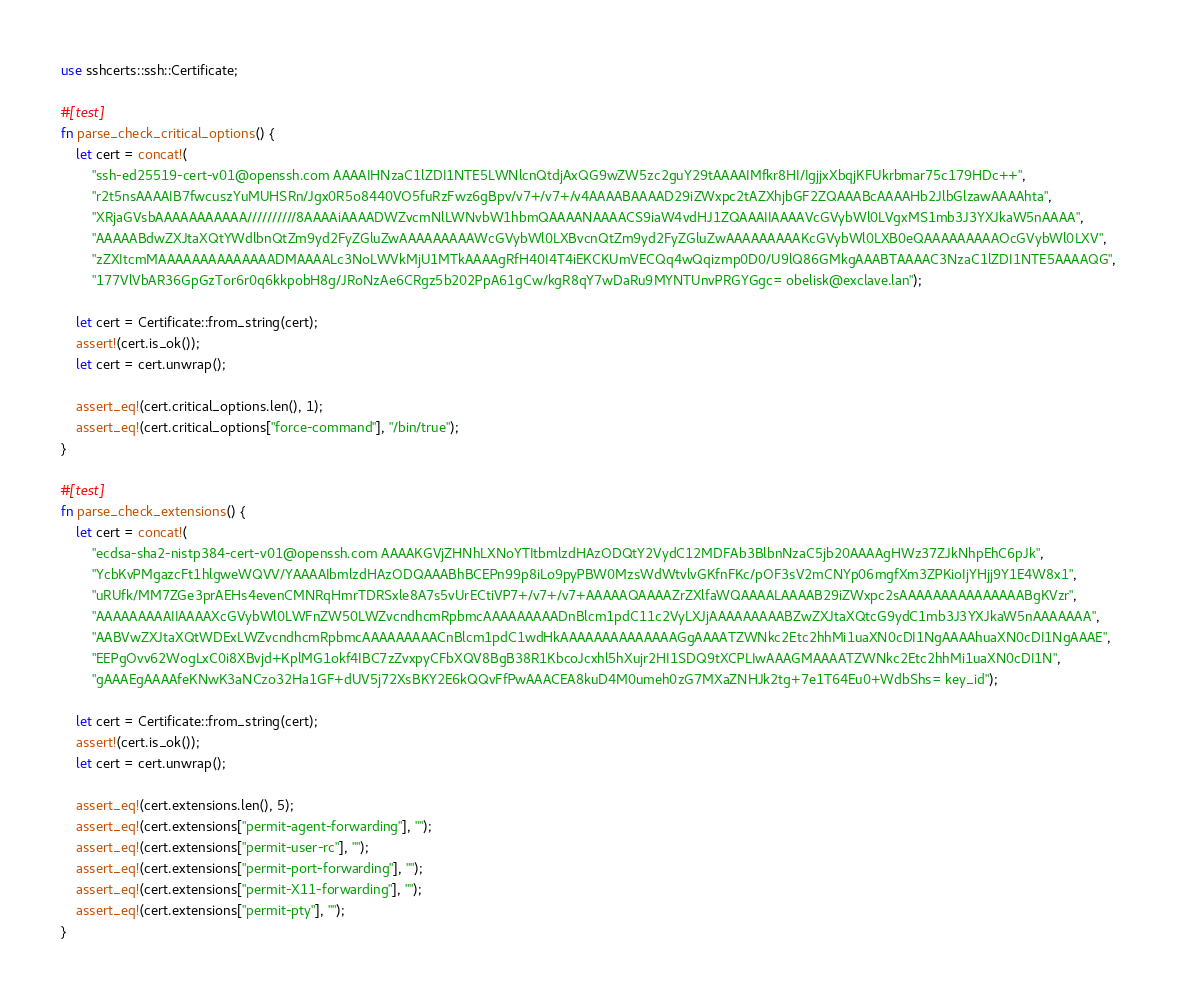<code> <loc_0><loc_0><loc_500><loc_500><_Rust_>use sshcerts::ssh::Certificate;

#[test]
fn parse_check_critical_options() {
    let cert = concat!(
        "ssh-ed25519-cert-v01@openssh.com AAAAIHNzaC1lZDI1NTE5LWNlcnQtdjAxQG9wZW5zc2guY29tAAAAIMfkr8HI/IgjjxXbqjKFUkrbmar75c179HDc++",
        "r2t5nsAAAAIB7fwcuszYuMUHSRn/Jgx0R5o8440VO5fuRzFwz6gBpv/v7+/v7+/v4AAAABAAAAD29iZWxpc2tAZXhjbGF2ZQAAABcAAAAHb2JlbGlzawAAAAhta",
        "XRjaGVsbAAAAAAAAAAA//////////8AAAAiAAAADWZvcmNlLWNvbW1hbmQAAAANAAAACS9iaW4vdHJ1ZQAAAIIAAAAVcGVybWl0LVgxMS1mb3J3YXJkaW5nAAAA",
        "AAAAABdwZXJtaXQtYWdlbnQtZm9yd2FyZGluZwAAAAAAAAAWcGVybWl0LXBvcnQtZm9yd2FyZGluZwAAAAAAAAAKcGVybWl0LXB0eQAAAAAAAAAOcGVybWl0LXV",
        "zZXItcmMAAAAAAAAAAAAAADMAAAALc3NoLWVkMjU1MTkAAAAgRfH40I4T4iEKCKUmVECQq4wQqizmp0D0/U9lQ86GMkgAAABTAAAAC3NzaC1lZDI1NTE5AAAAQG",
        "177VlVbAR36GpGzTor6r0q6kkpobH8g/JRoNzAe6CRgz5b202PpA61gCw/kgR8qY7wDaRu9MYNTUnvPRGYGgc= obelisk@exclave.lan");

    let cert = Certificate::from_string(cert);
    assert!(cert.is_ok());
    let cert = cert.unwrap();

    assert_eq!(cert.critical_options.len(), 1);
    assert_eq!(cert.critical_options["force-command"], "/bin/true");
}

#[test]
fn parse_check_extensions() {
    let cert = concat!(
        "ecdsa-sha2-nistp384-cert-v01@openssh.com AAAAKGVjZHNhLXNoYTItbmlzdHAzODQtY2VydC12MDFAb3BlbnNzaC5jb20AAAAgHWz37ZJkNhpEhC6pJk",
        "YcbKvPMgazcFt1hlgweWQVV/YAAAAIbmlzdHAzODQAAABhBCEPn99p8iLo9pyPBW0MzsWdWtvlvGKfnFKc/pOF3sV2mCNYp06mgfXm3ZPKioIjYHjj9Y1E4W8x1",
        "uRUfk/MM7ZGe3prAEHs4evenCMNRqHmrTDRSxle8A7s5vUrECtiVP7+/v7+/v7+AAAAAQAAAAZrZXlfaWQAAAALAAAAB29iZWxpc2sAAAAAAAAAAAAAAABgKVzr",
        "AAAAAAAAAIIAAAAXcGVybWl0LWFnZW50LWZvcndhcmRpbmcAAAAAAAAADnBlcm1pdC11c2VyLXJjAAAAAAAAABZwZXJtaXQtcG9ydC1mb3J3YXJkaW5nAAAAAAA",
        "AABVwZXJtaXQtWDExLWZvcndhcmRpbmcAAAAAAAAACnBlcm1pdC1wdHkAAAAAAAAAAAAAAGgAAAATZWNkc2Etc2hhMi1uaXN0cDI1NgAAAAhuaXN0cDI1NgAAAE",
        "EEPgOvv62WogLxC0i8XBvjd+KplMG1okf4IBC7zZvxpyCFbXQV8BgB38R1KbcoJcxhl5hXujr2HI1SDQ9tXCPLIwAAAGMAAAATZWNkc2Etc2hhMi1uaXN0cDI1N",
        "gAAAEgAAAAfeKNwK3aNCzo32Ha1GF+dUV5j72XsBKY2E6kQQvFfPwAAACEA8kuD4M0umeh0zG7MXaZNHJk2tg+7e1T64Eu0+WdbShs= key_id");

    let cert = Certificate::from_string(cert);
    assert!(cert.is_ok());
    let cert = cert.unwrap();

    assert_eq!(cert.extensions.len(), 5);
    assert_eq!(cert.extensions["permit-agent-forwarding"], "");
    assert_eq!(cert.extensions["permit-user-rc"], "");
    assert_eq!(cert.extensions["permit-port-forwarding"], "");
    assert_eq!(cert.extensions["permit-X11-forwarding"], "");
    assert_eq!(cert.extensions["permit-pty"], "");
}</code> 